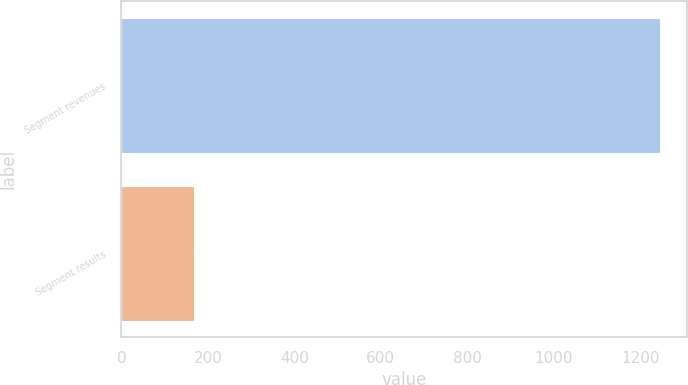<chart> <loc_0><loc_0><loc_500><loc_500><bar_chart><fcel>Segment revenues<fcel>Segment results<nl><fcel>1245<fcel>169<nl></chart> 